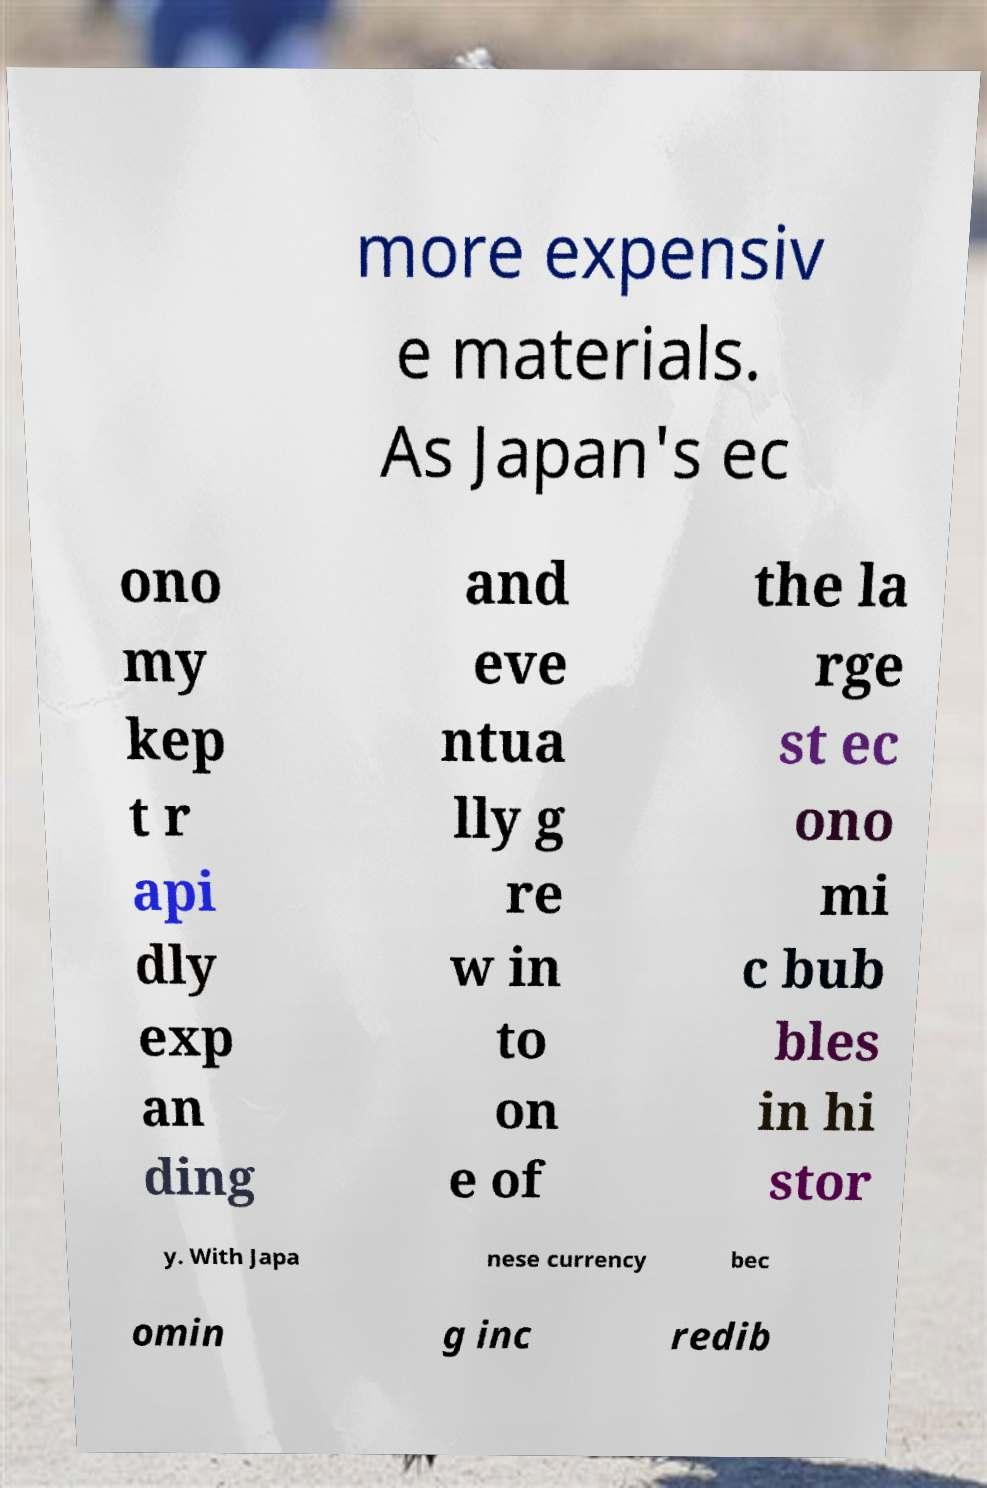I need the written content from this picture converted into text. Can you do that? more expensiv e materials. As Japan's ec ono my kep t r api dly exp an ding and eve ntua lly g re w in to on e of the la rge st ec ono mi c bub bles in hi stor y. With Japa nese currency bec omin g inc redib 